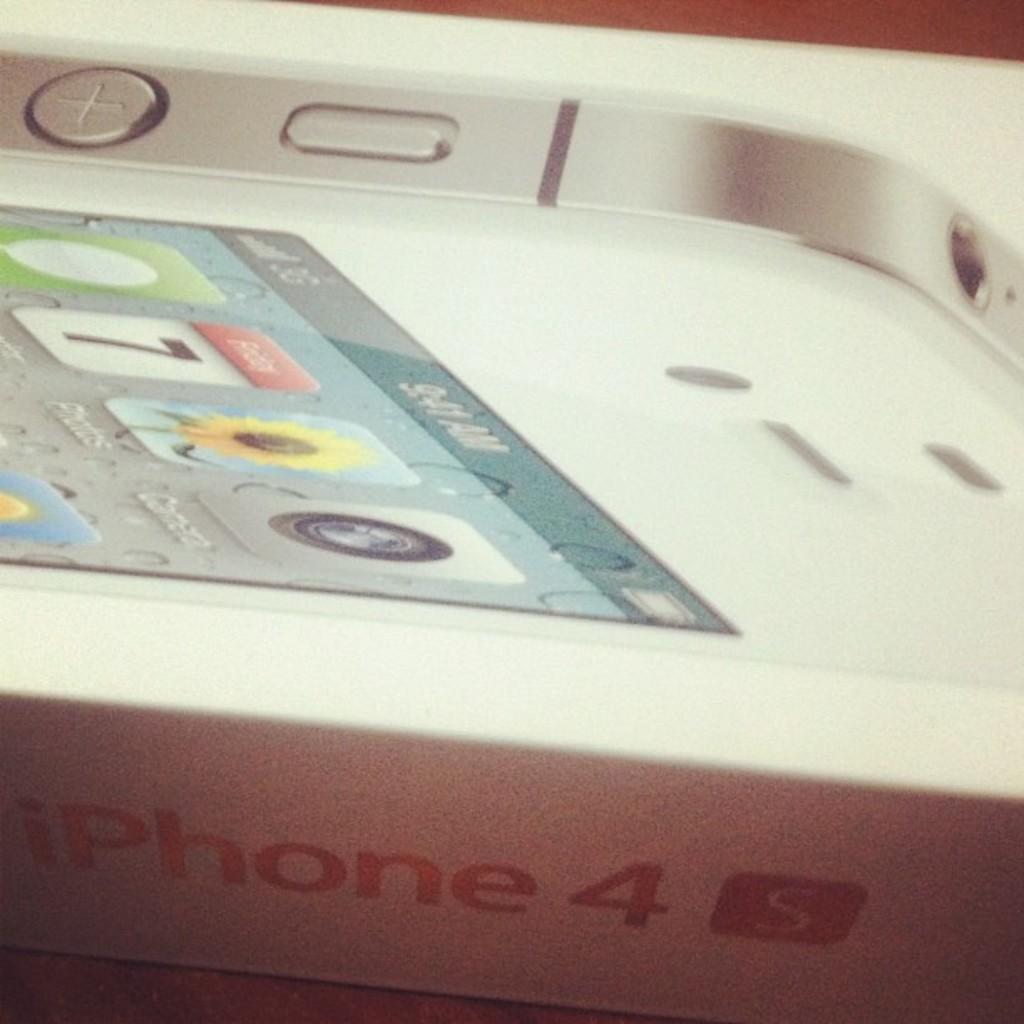What brand and model is shown?
Keep it short and to the point. Iphone 4s. 